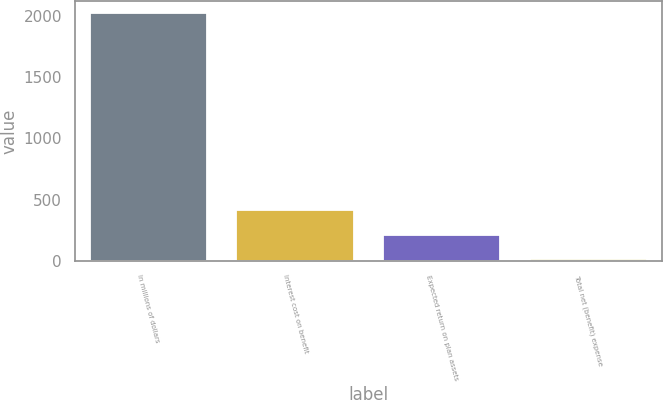Convert chart to OTSL. <chart><loc_0><loc_0><loc_500><loc_500><bar_chart><fcel>In millions of dollars<fcel>Interest cost on benefit<fcel>Expected return on plan assets<fcel>Total net (benefit) expense<nl><fcel>2018<fcel>412.4<fcel>211.7<fcel>11<nl></chart> 